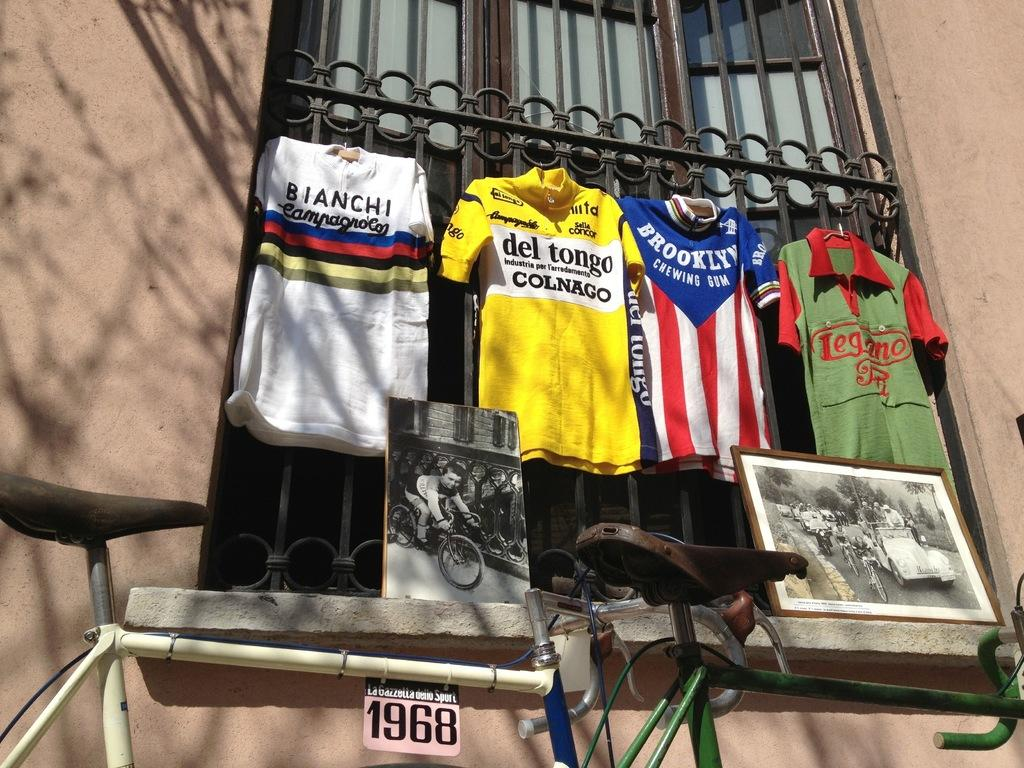<image>
Offer a succinct explanation of the picture presented. Four shirts hanging outside one of them says del tongo on it. 